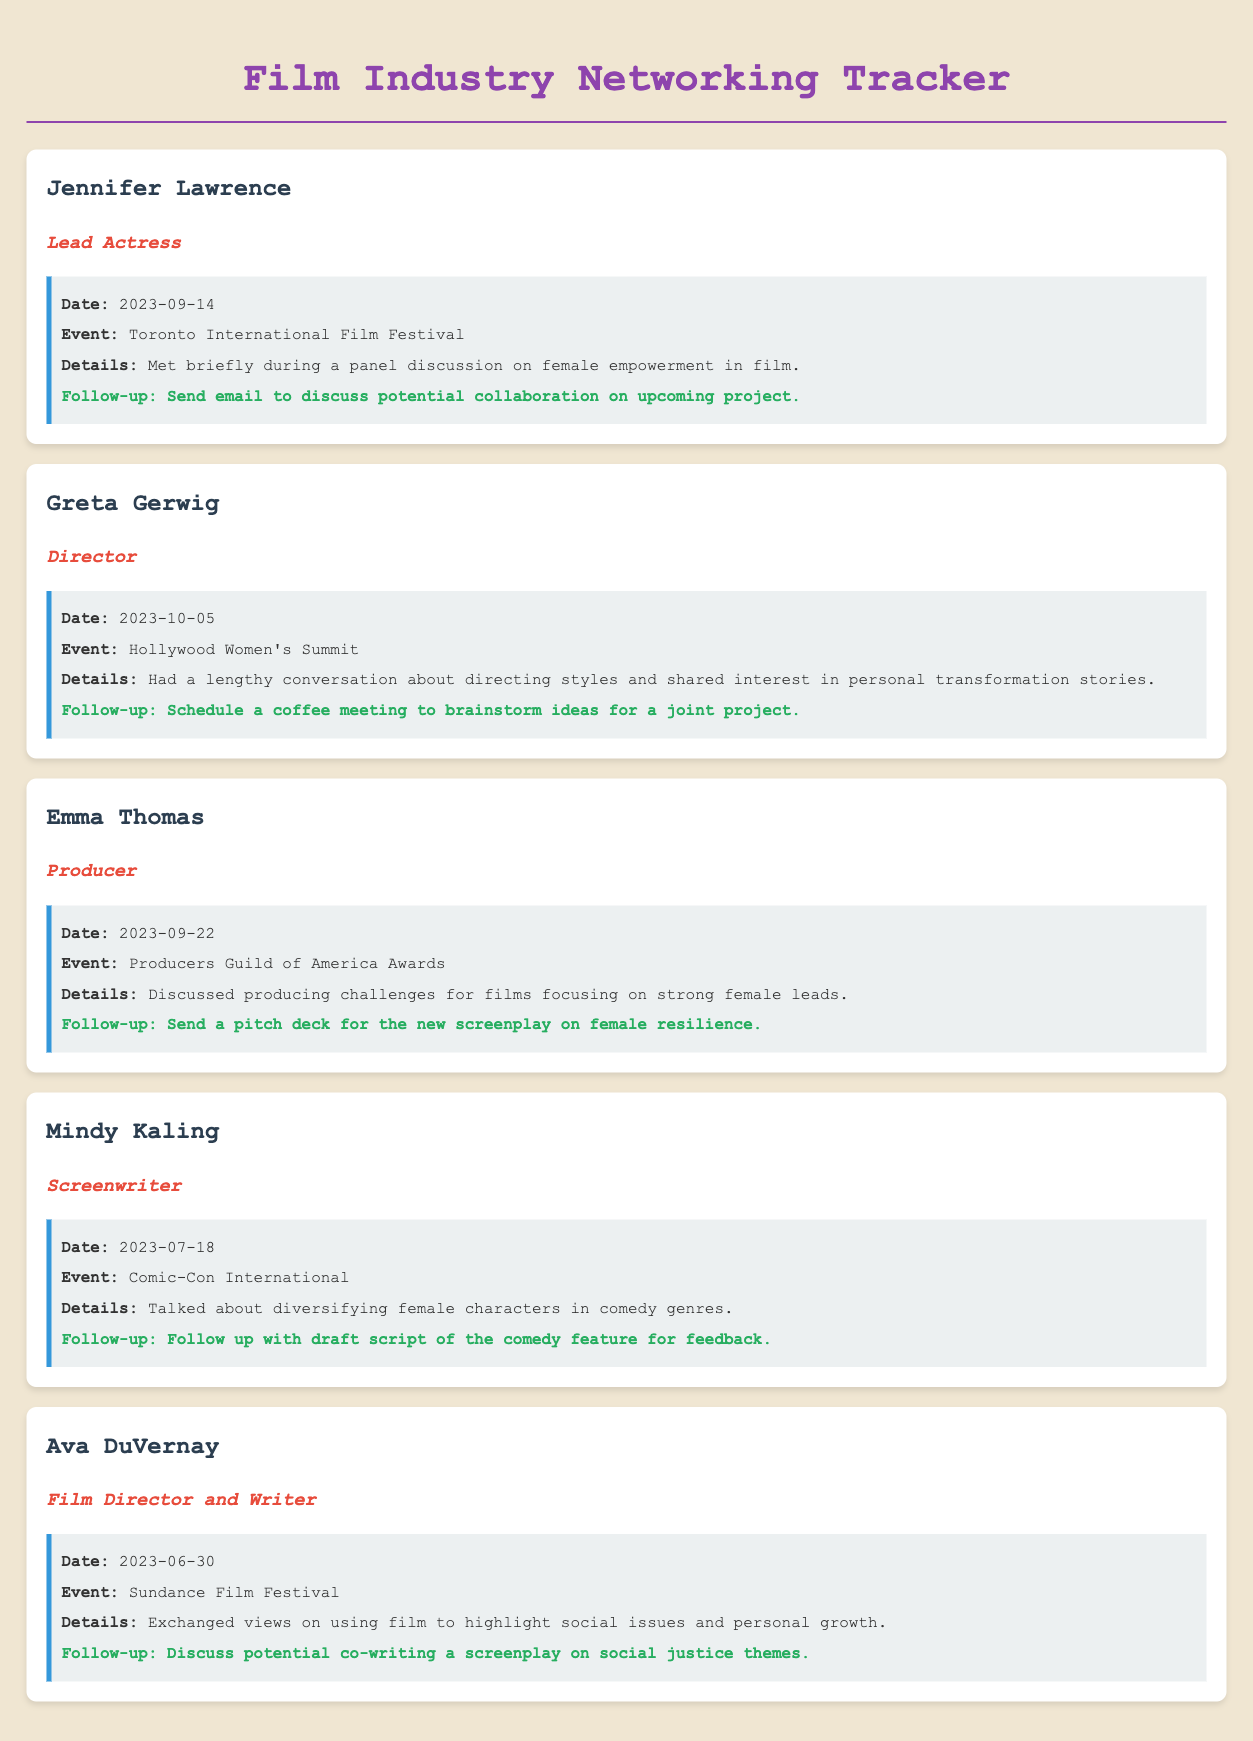What is the name of the lead actress? The document lists Jennifer Lawrence as the lead actress.
Answer: Jennifer Lawrence Which event did Greta Gerwig attend? The document specifies that Greta Gerwig attended the Hollywood Women's Summit.
Answer: Hollywood Women's Summit What type of role does Ava DuVernay have? Ava DuVernay is identified as a Film Director and Writer in the document.
Answer: Film Director and Writer On what date did the interaction with Mindy Kaling occur? According to the document, the interaction with Mindy Kaling took place on July 18, 2023.
Answer: 2023-07-18 What was the follow-up action with Emma Thomas? The document states the follow-up action with Emma Thomas is to send a pitch deck.
Answer: Send a pitch deck for the new screenplay on female resilience What common theme was discussed between Greta Gerwig and the screenwriter? The interaction highlighted their shared interest in personal transformation stories.
Answer: Personal transformation stories How many contacts are listed in the document? The document contains a total of five contacts.
Answer: Five In which month did the interaction with Jennifer Lawrence take place? The document indicates that the interaction with Jennifer Lawrence took place in September.
Answer: September 